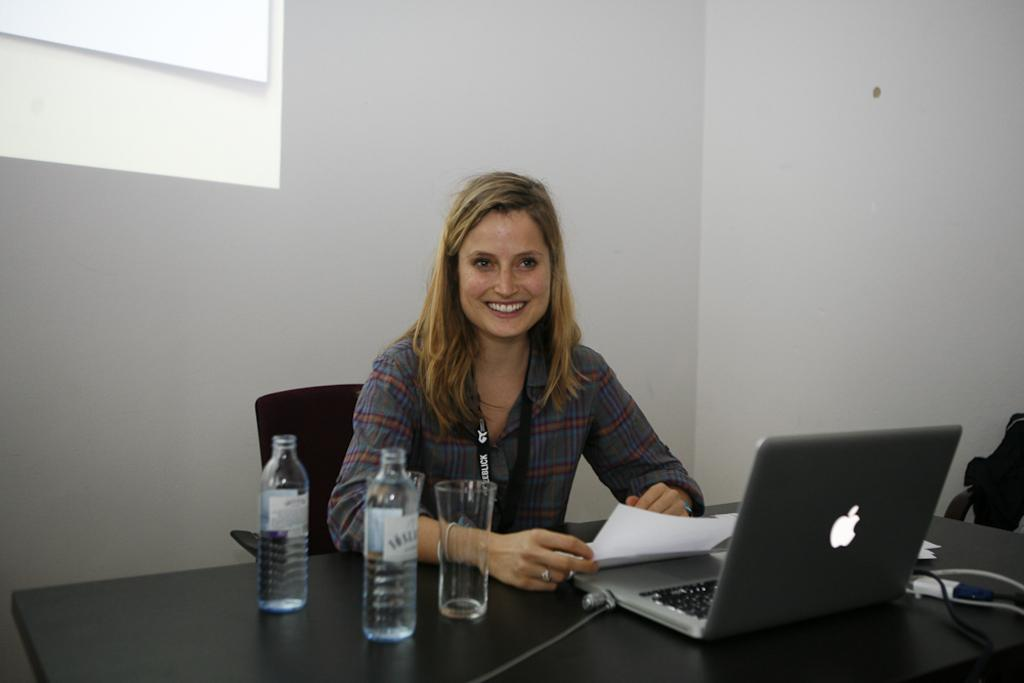What is the woman in the image doing? The woman is sitting on a chair and holding a paper. What is the woman's facial expression in the image? The woman is smiling. What objects can be seen on the table in the image? There are bottles, a glass, a laptop, and cables on the table. How many sheep can be seen in the image? There are no sheep present in the image. What is the woman's nose doing in the image? The woman's nose is not performing any action in the image; it is simply part of her face. 